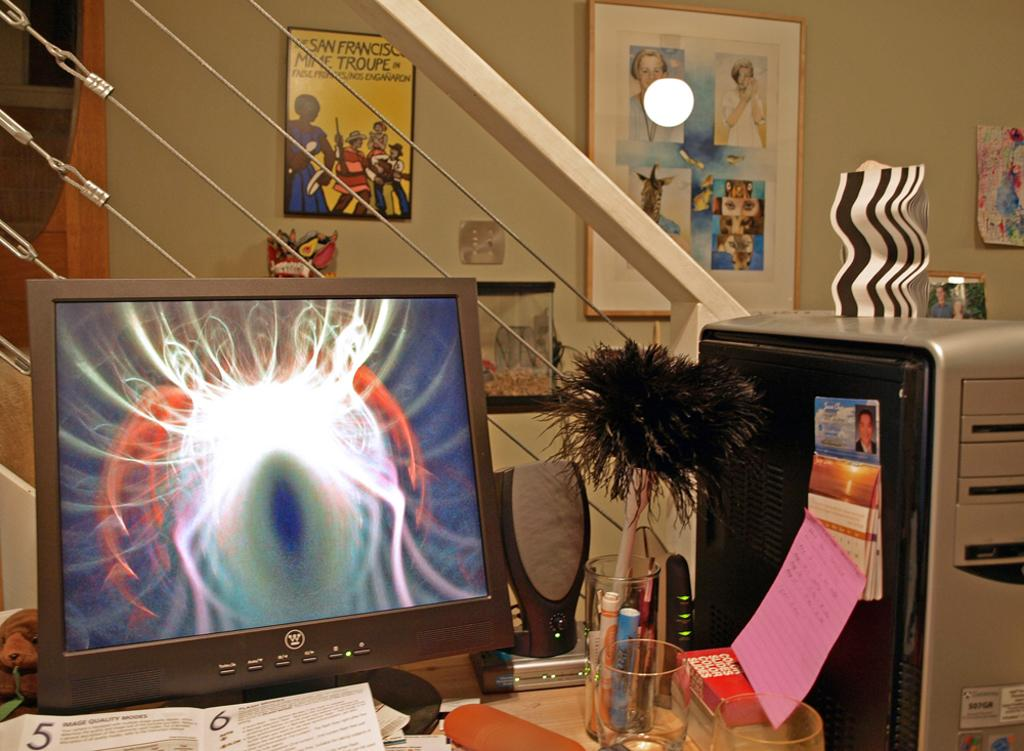<image>
Describe the image concisely. A computer monitor with an abstract pattern displayed has the letter "W" on its frame. 